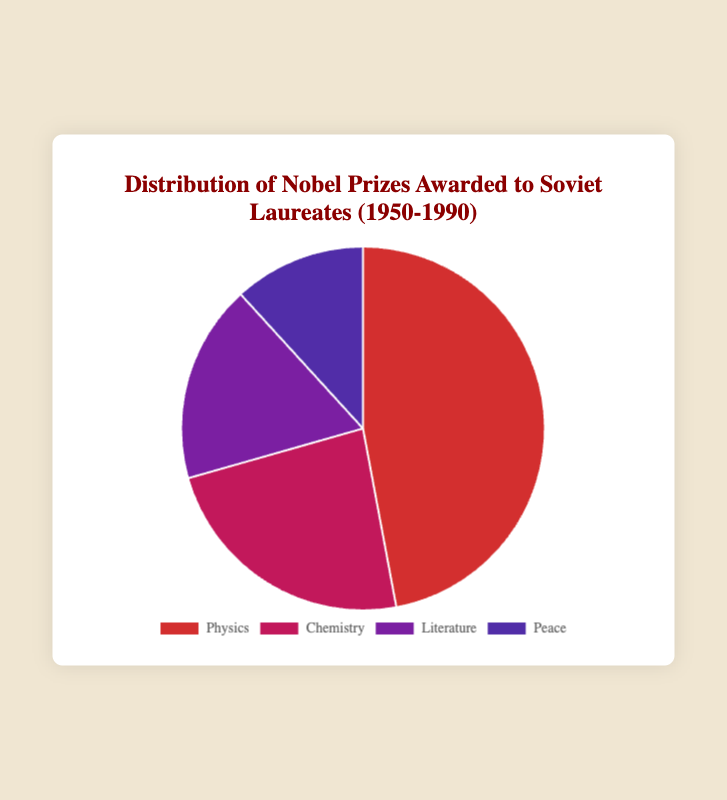What is the total number of Nobel Prizes awarded to Soviet laureates from 1950 to 1990? To find the total number of Nobel Prizes, sum all the individual counts: 8 (Physics) + 4 (Chemistry) + 3 (Literature) + 2 (Peace). This equals 17
Answer: 17 Which category received the highest number of Nobel Prizes? By visually comparing the data points, the Physics category has the highest count of 8
Answer: Physics What is the ratio of Nobel Prizes in Physics to those in Chemistry? The count for Physics is 8 and for Chemistry is 4. The ratio is therefore 8:4, which simplifies to 2:1
Answer: 2:1 How many more Nobel Prizes were awarded in Physics compared to Literature? Subtract the number of Literature prizes (3) from the number of Physics prizes (8). This gives 8 - 3 = 5
Answer: 5 What percentage of the total Nobel Prizes were awarded in the Peace category? First calculate the total number of prizes (17). Then, divide the Peace prizes (2) by the total and multiply by 100 to get the percentage: (2/17) * 100 ≈ 11.76%
Answer: ~11.76% Which categories received fewer than 4 Nobel Prizes? The categories that received fewer than 4 prizes are Literature (3) and Peace (2)
Answer: Literature and Peace What is the difference in the number of Nobel Prizes between the category with the most laureates and the category with the fewest laureates? The category with the most laureates is Physics with 8 prizes, and the category with the fewest laureates is Peace with 2 prizes. The difference is 8 - 2 = 6
Answer: 6 If we combine the Nobel Prizes for Chemistry and Literature, how many would that be? Add the number of Chemistry prizes (4) to the number of Literature prizes (3). This gives 4 + 3 = 7
Answer: 7 Which category has the second-highest number of Nobel Prizes? By visually comparing the numbers, Chemistry has the second-highest count at 4
Answer: Chemistry 